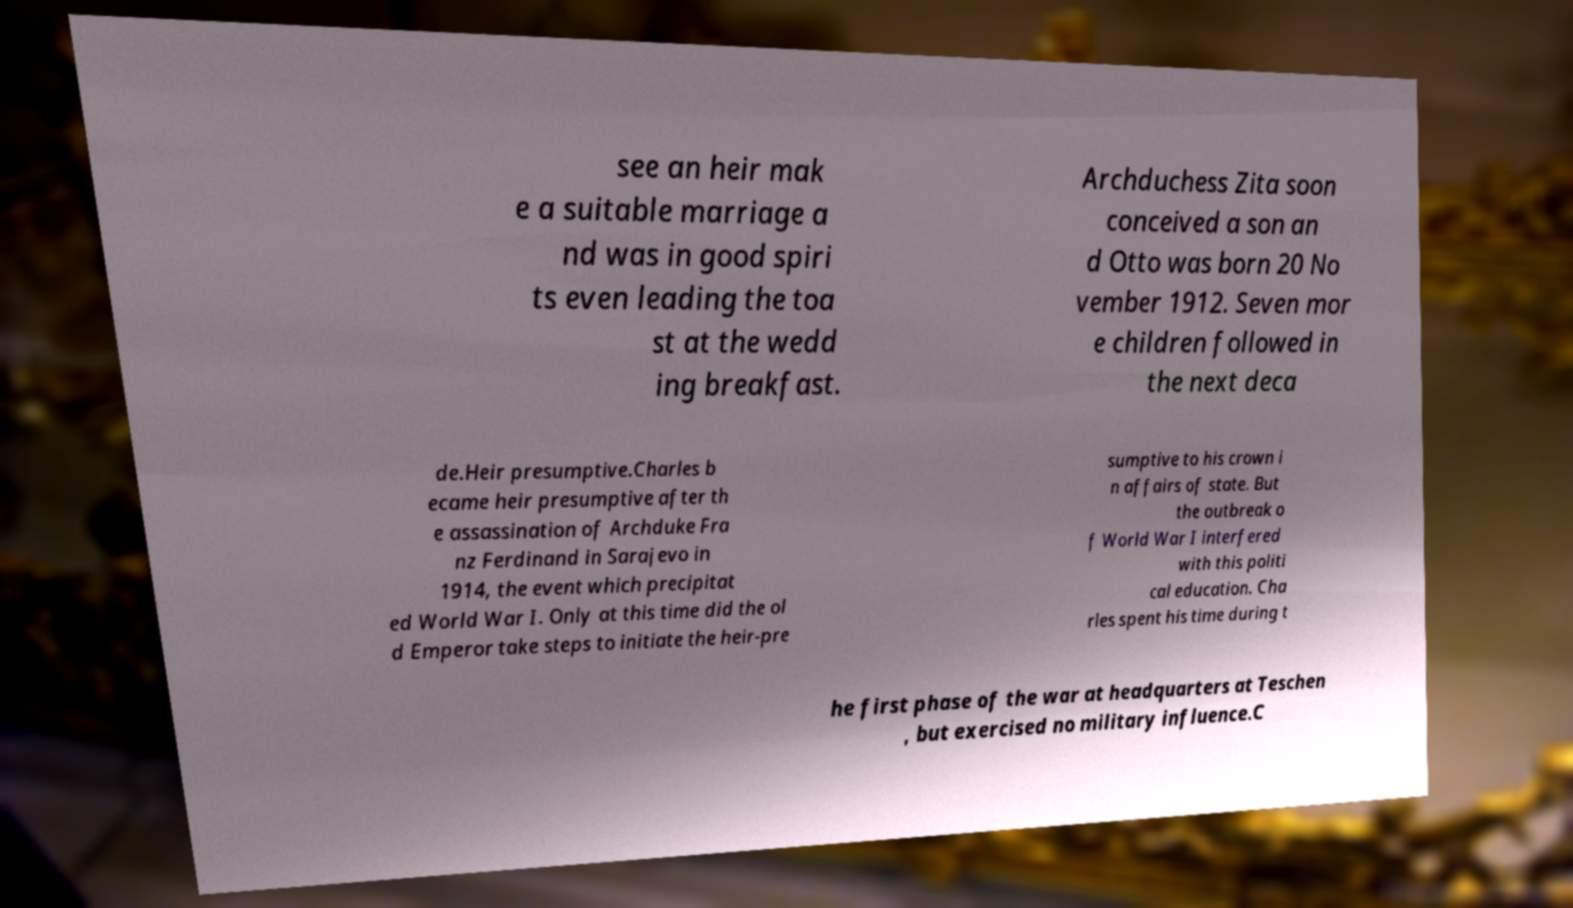There's text embedded in this image that I need extracted. Can you transcribe it verbatim? see an heir mak e a suitable marriage a nd was in good spiri ts even leading the toa st at the wedd ing breakfast. Archduchess Zita soon conceived a son an d Otto was born 20 No vember 1912. Seven mor e children followed in the next deca de.Heir presumptive.Charles b ecame heir presumptive after th e assassination of Archduke Fra nz Ferdinand in Sarajevo in 1914, the event which precipitat ed World War I. Only at this time did the ol d Emperor take steps to initiate the heir-pre sumptive to his crown i n affairs of state. But the outbreak o f World War I interfered with this politi cal education. Cha rles spent his time during t he first phase of the war at headquarters at Teschen , but exercised no military influence.C 